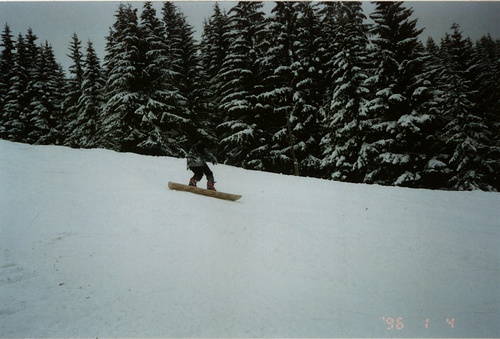Describe the objects in this image and their specific colors. I can see people in white, black, darkgray, gray, and maroon tones and snowboard in white, gray, black, and darkgray tones in this image. 